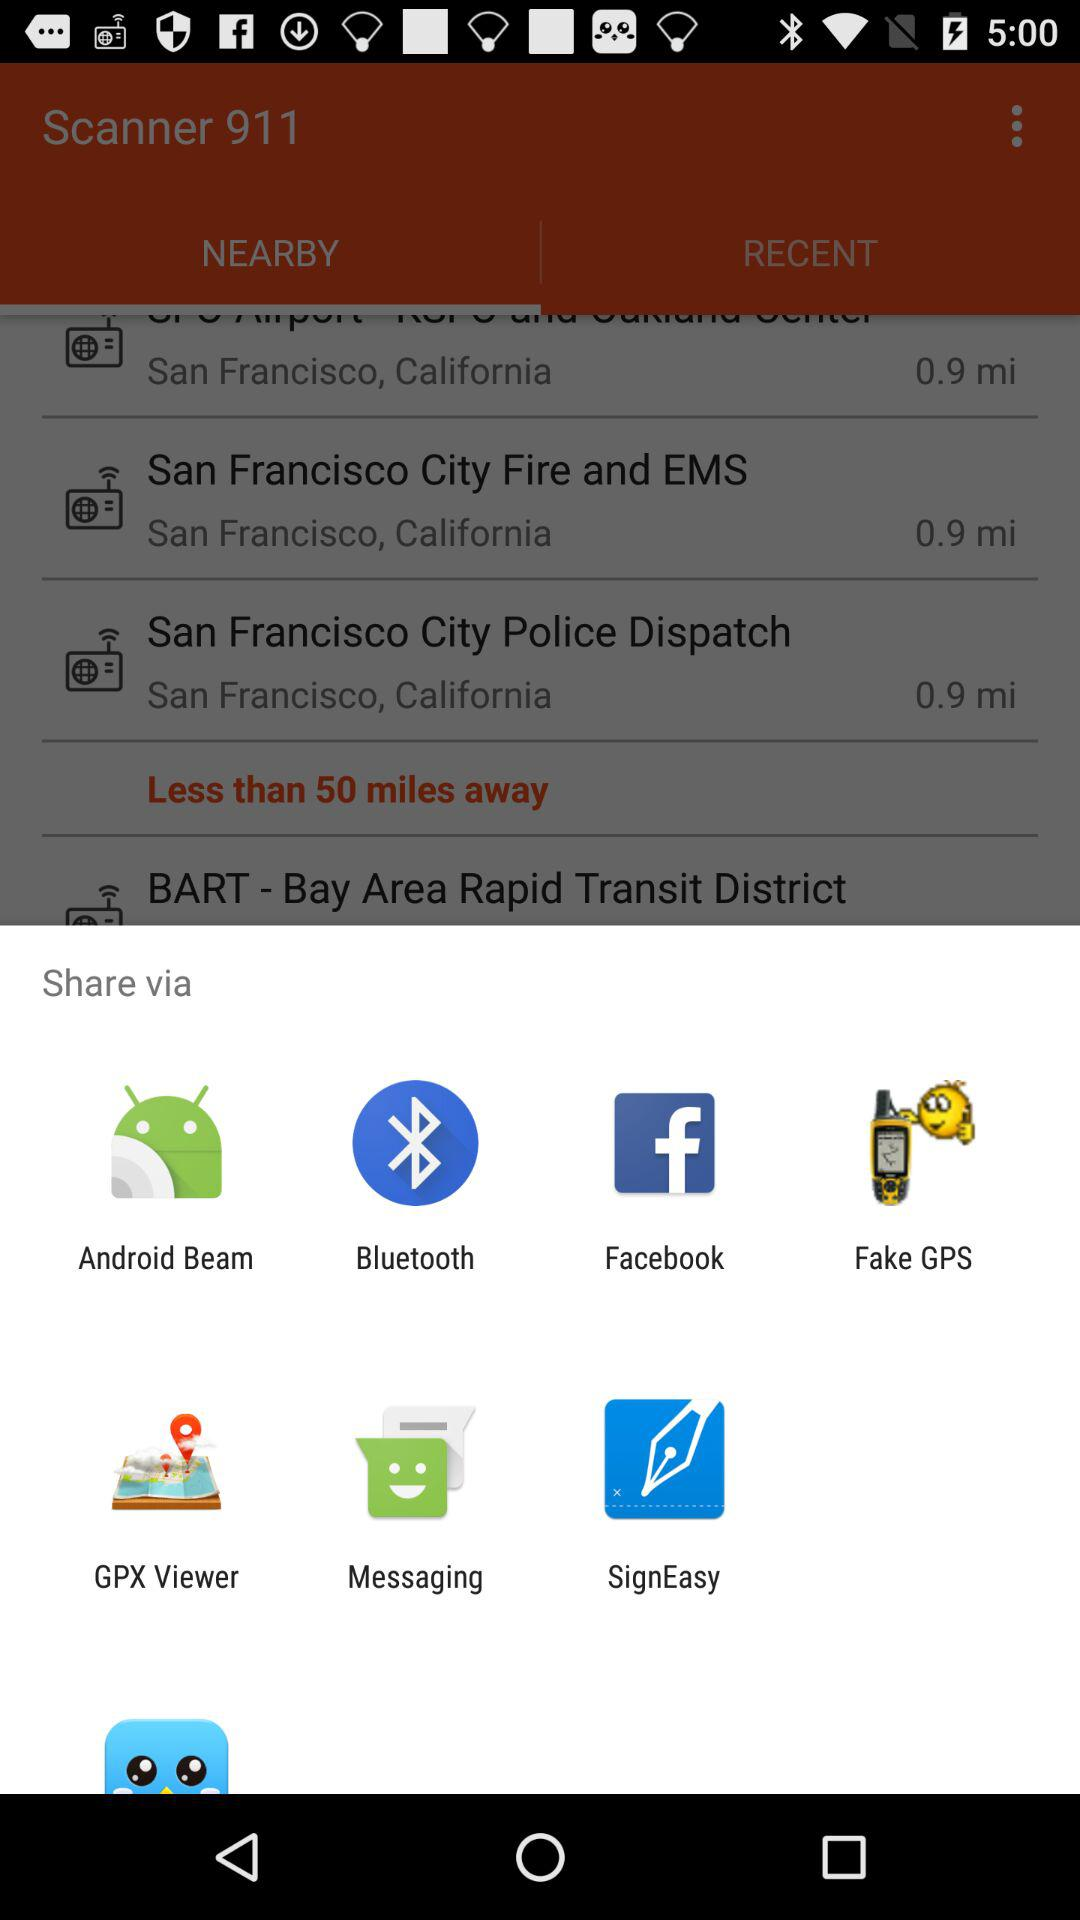Which are the different sharing options? The different sharing options are "Android Beam", "Bluetooth", "Facebook", "Fake GPS", "GPX Viewer", "Messaging" and "SignEasy". 